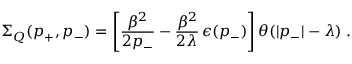<formula> <loc_0><loc_0><loc_500><loc_500>\Sigma _ { Q } ( p _ { + } , p _ { - } ) = \left [ \frac { \beta ^ { 2 } } { 2 p _ { - } } - \frac { \beta ^ { 2 } } { 2 \lambda } \, \epsilon ( p _ { - } ) \right ] \theta ( | p _ { - } | - \lambda ) \, .</formula> 